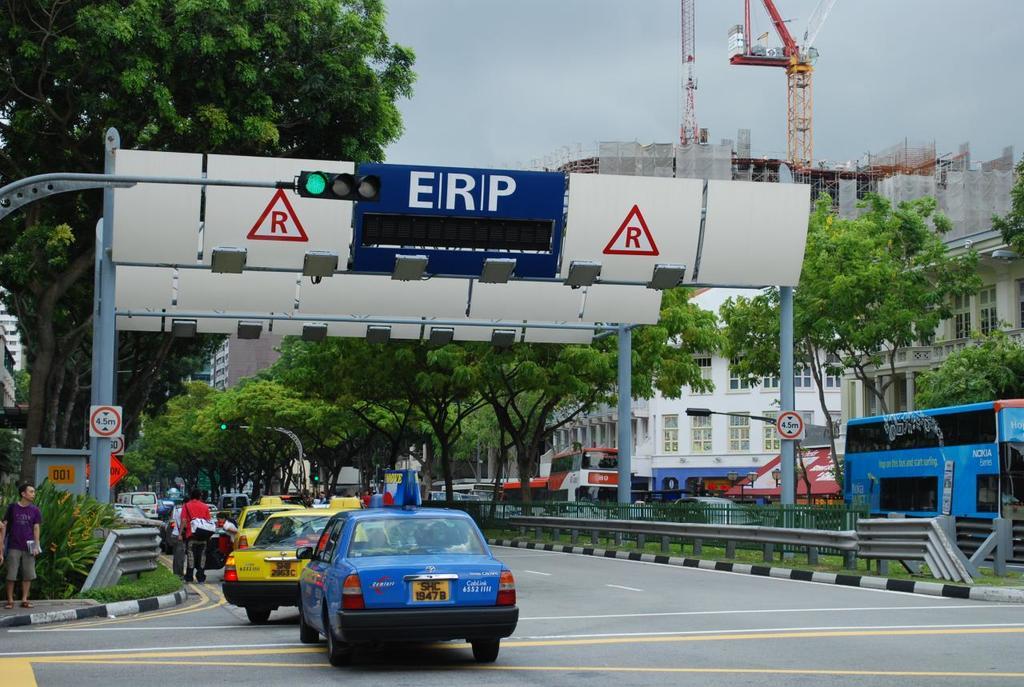What color is the traffic light?
Your answer should be very brief. Green. What is the sign next to the traffic light?
Give a very brief answer. Erp. 